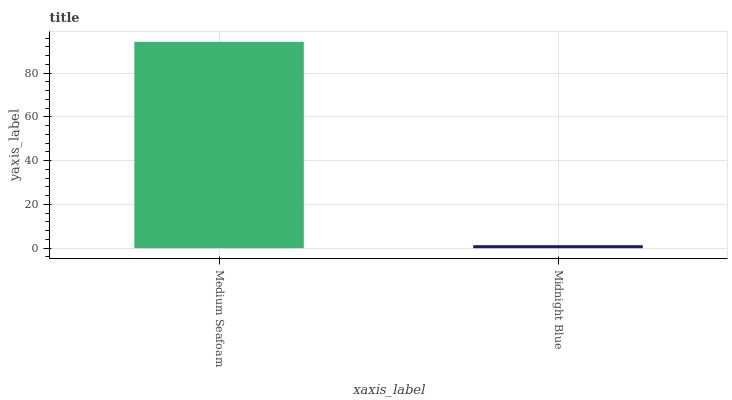Is Midnight Blue the minimum?
Answer yes or no. Yes. Is Medium Seafoam the maximum?
Answer yes or no. Yes. Is Midnight Blue the maximum?
Answer yes or no. No. Is Medium Seafoam greater than Midnight Blue?
Answer yes or no. Yes. Is Midnight Blue less than Medium Seafoam?
Answer yes or no. Yes. Is Midnight Blue greater than Medium Seafoam?
Answer yes or no. No. Is Medium Seafoam less than Midnight Blue?
Answer yes or no. No. Is Medium Seafoam the high median?
Answer yes or no. Yes. Is Midnight Blue the low median?
Answer yes or no. Yes. Is Midnight Blue the high median?
Answer yes or no. No. Is Medium Seafoam the low median?
Answer yes or no. No. 